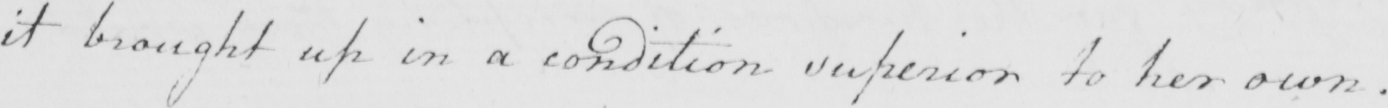Please provide the text content of this handwritten line. it brought up in a condition superior to her own . 